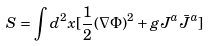<formula> <loc_0><loc_0><loc_500><loc_500>S = \int d ^ { 2 } x [ \frac { 1 } { 2 } ( \nabla \Phi ) ^ { 2 } + g J ^ { a } \bar { J } ^ { a } ]</formula> 